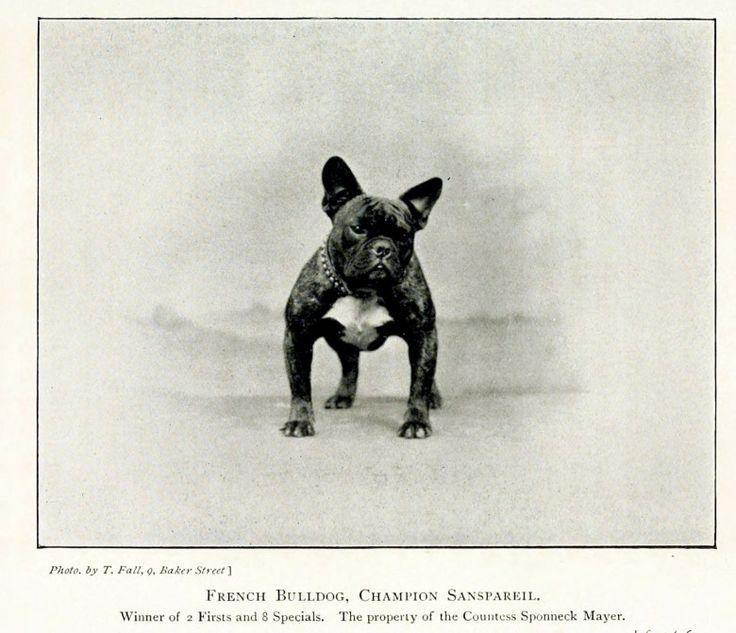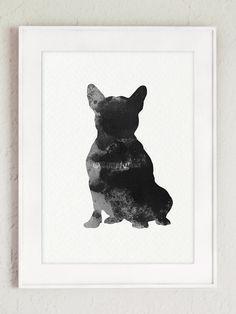The first image is the image on the left, the second image is the image on the right. Examine the images to the left and right. Is the description "A total of seven dog figures are shown." accurate? Answer yes or no. No. The first image is the image on the left, the second image is the image on the right. Given the left and right images, does the statement "There are at least two living breathing Bulldogs looking forward." hold true? Answer yes or no. No. 